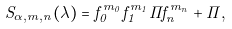<formula> <loc_0><loc_0><loc_500><loc_500>S _ { \alpha , m , n } ( \lambda ) = f _ { 0 } ^ { m _ { 0 } } f _ { 1 } ^ { m _ { 1 } } \cdots f _ { n } ^ { m _ { n } } + \cdots ,</formula> 